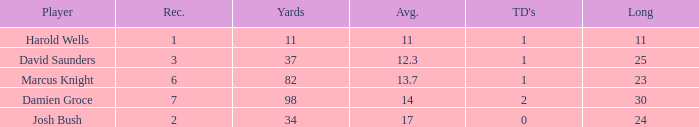How many TDs are there were the long is smaller than 23? 1.0. 